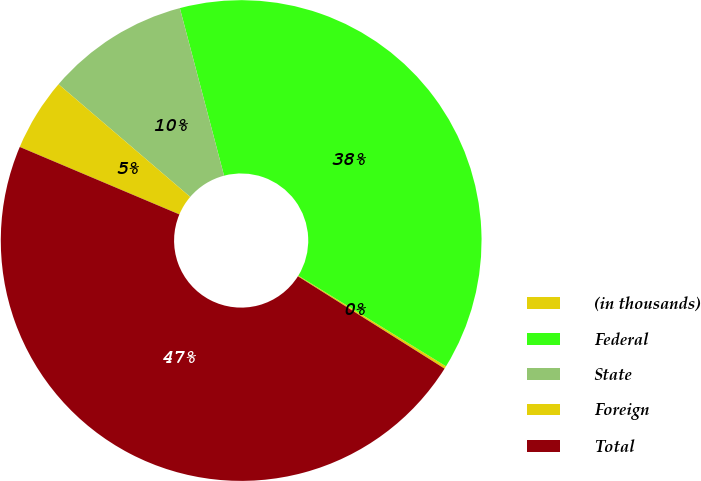Convert chart. <chart><loc_0><loc_0><loc_500><loc_500><pie_chart><fcel>(in thousands)<fcel>Federal<fcel>State<fcel>Foreign<fcel>Total<nl><fcel>0.18%<fcel>37.87%<fcel>9.63%<fcel>4.9%<fcel>47.42%<nl></chart> 